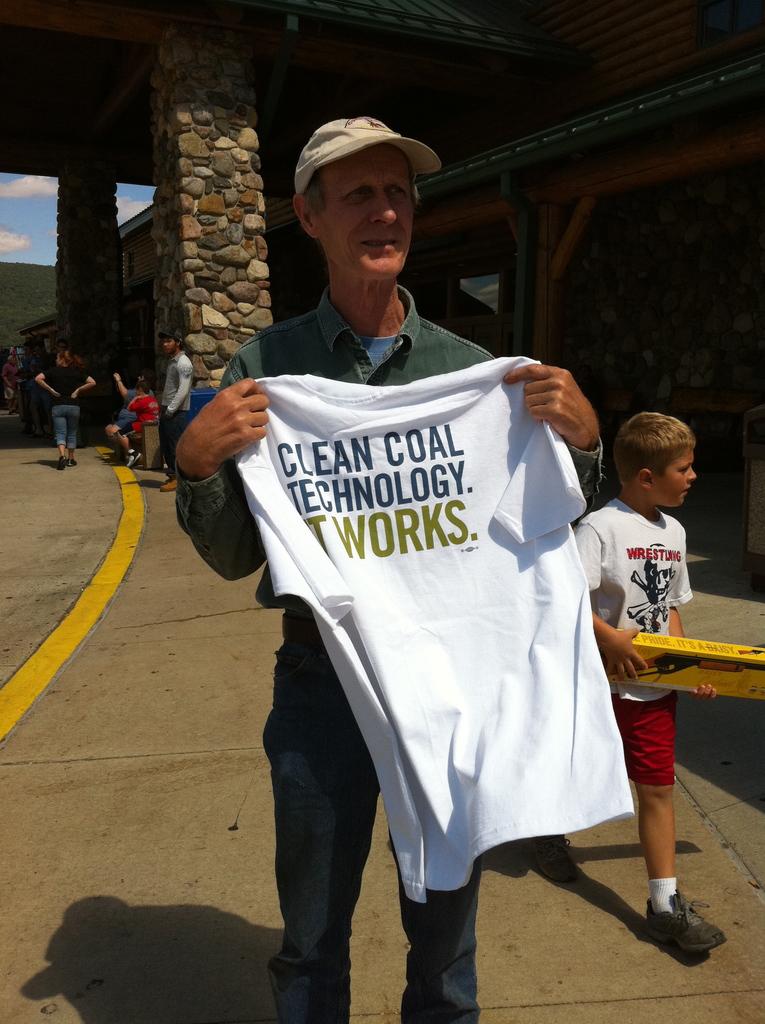What is it that works?
Make the answer very short. Clean coal technology. 